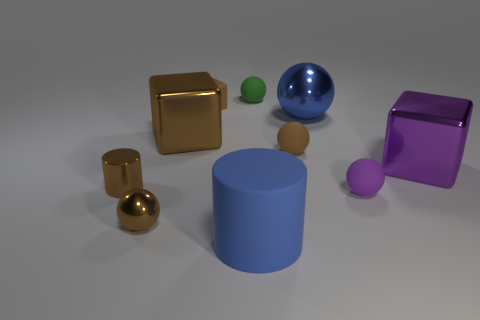There is a purple object that is the same material as the small brown cylinder; what shape is it?
Your response must be concise. Cube. There is a big rubber object; does it have the same shape as the small brown rubber object that is left of the tiny green ball?
Ensure brevity in your answer.  No. The large thing on the left side of the blue matte cylinder in front of the tiny cylinder is made of what material?
Offer a terse response. Metal. Is the number of metal balls in front of the small brown matte sphere the same as the number of small blue rubber balls?
Your answer should be very brief. No. Is there any other thing that is made of the same material as the purple sphere?
Your answer should be compact. Yes. Do the sphere that is left of the green rubber sphere and the large metal cube right of the large matte thing have the same color?
Provide a succinct answer. No. How many big objects are both behind the metal cylinder and right of the brown matte cube?
Your response must be concise. 2. What number of other objects are the same shape as the big blue matte thing?
Your response must be concise. 1. Are there more shiny balls that are behind the big blue metal ball than tiny matte cubes?
Provide a short and direct response. No. The big shiny block that is right of the large sphere is what color?
Give a very brief answer. Purple. 